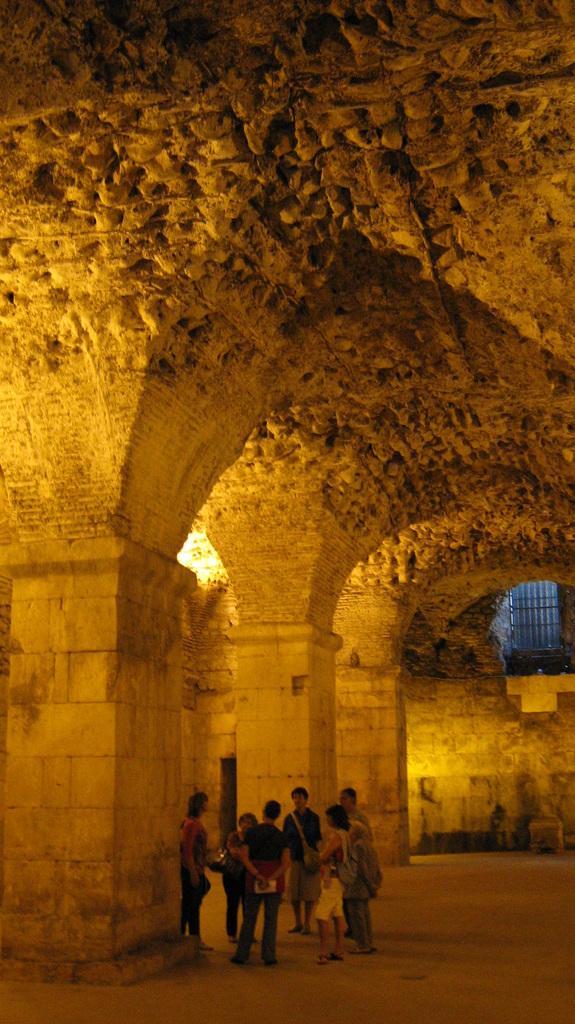Please provide a concise description of this image. This is a building, where people are standing. 